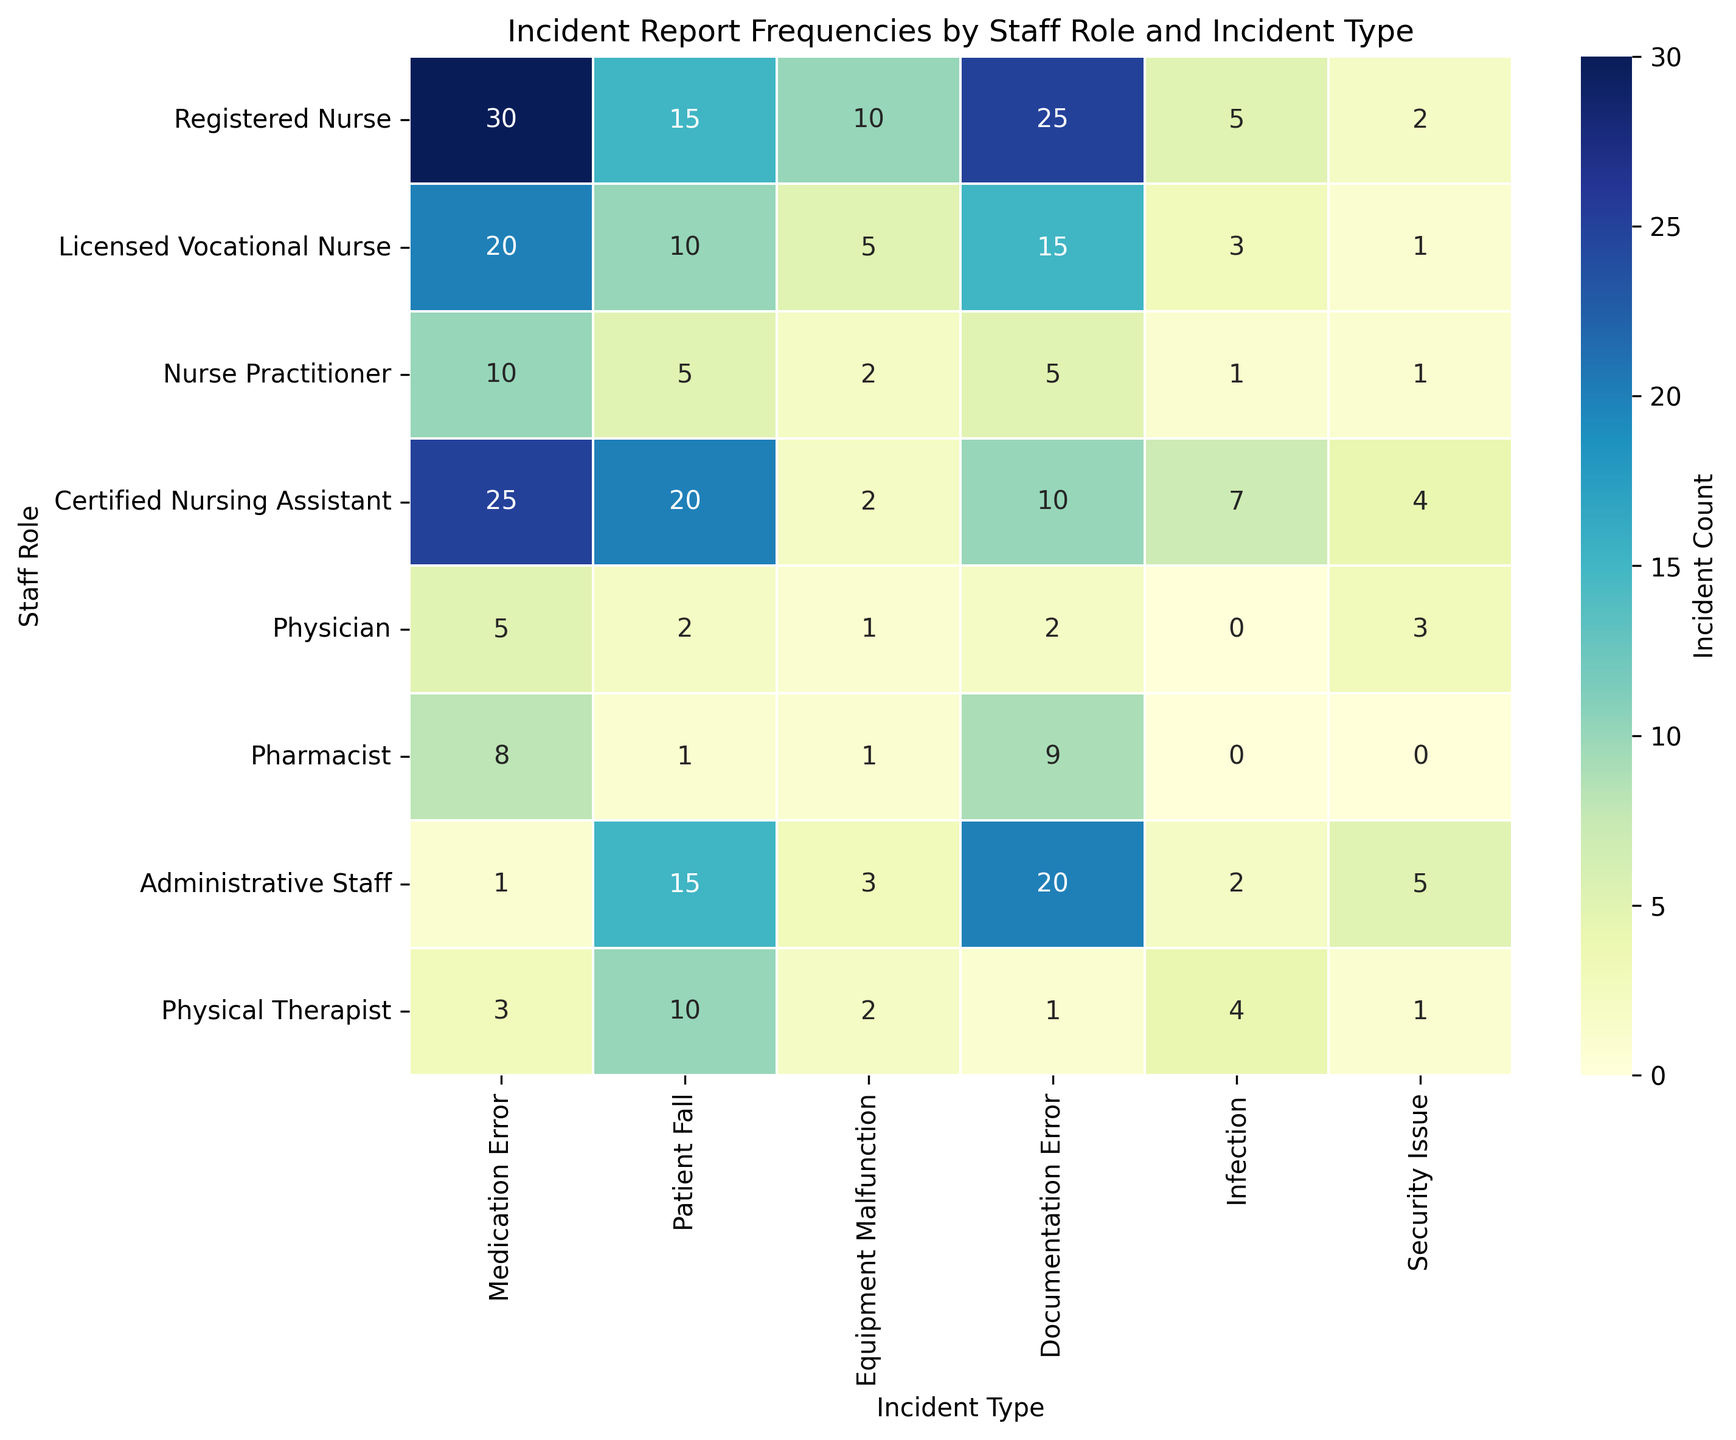Which staff role reports the highest number of medication errors? To find the staff role reporting the highest number of medication errors, look at the column for 'Medication Error' and identify the row with the highest number. In this case, 'Registered Nurse' with 30 reports has the highest number of medication errors.
Answer: Registered Nurse Which incident type has the highest frequency reported by Licensed Vocational Nurses? Look at the row for 'Licensed Vocational Nurse' and identify the column with the highest number. Here, 'Medication Error' with 20 reports is the highest.
Answer: Medication Error Do Certified Nursing Assistants report more or fewer falls compared to Registered Nurses? Compare the 'Patient Fall' numbers between the two roles. Certified Nursing Assistants report 20 falls, whereas Registered Nurses report 15 falls. Therefore, Certified Nursing Assistants report more falls.
Answer: More How many more equipment malfunctions are reported by Registered Nurses compared to Nurse Practitioners? Calculate the difference between the numbers in the 'Equipment Malfunction' column for both roles: 10 (Registered Nurse) - 2 (Nurse Practitioner) = 8.
Answer: 8 What is the total number of infection reports across all staff roles? Sum the values in the 'Infection' column: 5 (Registered Nurse) + 3 (Licensed Vocational Nurse) + 1 (Nurse Practitioner) + 7 (Certified Nursing Assistant) + 0 (Physician) + 0 (Pharmacist) + 2 (Administrative Staff) + 4 (Physical Therapist) = 22.
Answer: 22 Which incident type reported by Administrative Staff has the highest frequency, and what is its visual color attribute? Identify the highest value in the 'Administrative Staff' row and look at the associated cell in the heatmap. The highest frequency is for 'Documentation Error' with 20 reports. The visual color attribute for high values in this heatmap is dark blue.
Answer: Documentation Error, dark blue What's the average number of security issue reports across all staff roles? Sum the numbers in the 'Security Issue' column and divide by the number of staff roles. Sum: 2 (Registered Nurse) + 1 (Licensed Vocational Nurse) + 1 (Nurse Practitioner) + 4 (Certified Nursing Assistant) + 3 (Physician) + 0 (Pharmacist) + 5 (Administrative Staff) + 1 (Physical Therapist) = 17. Average = 17 / 8 = 2.125
Answer: 2.125 Do Nurse Practitioners report more documentation errors or equipment malfunctions? Compare the numbers in the 'Documentation Error' (5 reports) and 'Equipment Malfunction' (2 reports) columns for Nurse Practitioners. Nurse Practitioners report more documentation errors than equipment malfunctions.
Answer: Documentation Errors What is the combined total of incident reports for the 'Equipment Malfunction' and 'Security Issue' categories reported by Physical Therapists? Add the values in the 'Equipment Malfunction' and 'Security Issue' columns for the 'Physical Therapist' row: 2 (Equipment Malfunction) + 1 (Security Issue) = 3.
Answer: 3 Which staff roles report fewer than 10 medication errors? Look at the 'Medication Error' column and identify the roles with numbers less than 10. Nurse Practitioner (10), Pharmacist (8), and Physical Therapist (3) all report fewer than 10 medication errors.
Answer: Nurse Practitioner, Pharmacist, Physical Therapist 